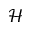Convert formula to latex. <formula><loc_0><loc_0><loc_500><loc_500>\mathcal { H }</formula> 